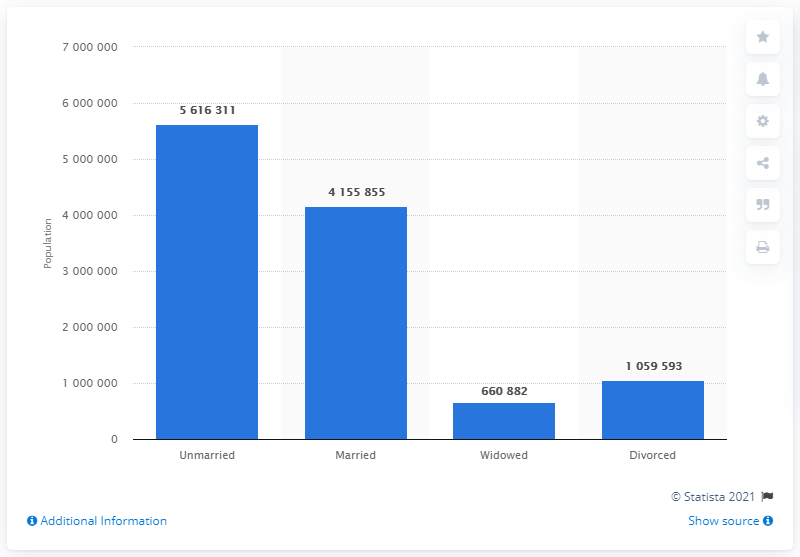Indicate a few pertinent items in this graphic. In 2020, there were 561,631 unmarried Belgians. 